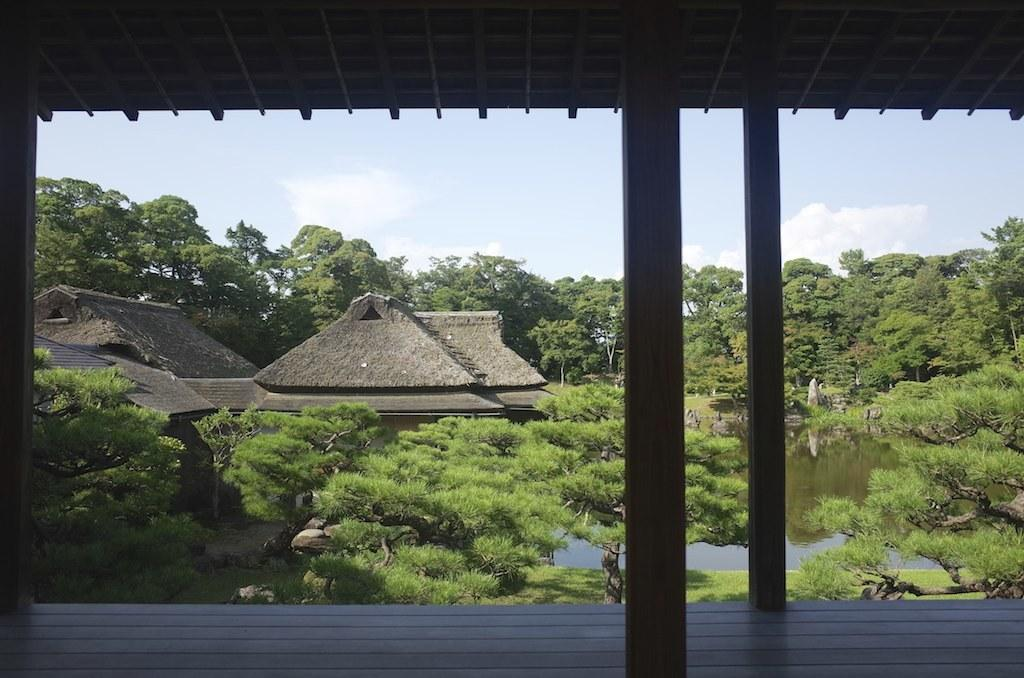What type of vegetation can be seen in the image? There are trees in the image. What is the color of the trees? The trees are green in color. What type of structures are present in the image? There are houses in the image. What natural element is visible in the image? There is water visible in the image. What is the color of the sky in the background? The sky in the background is white in color. Where is the basin located in the image? There is no basin present in the image. What type of cream can be seen on the trees in the image? There is no cream present on the trees in the image; they are simply green in color. 